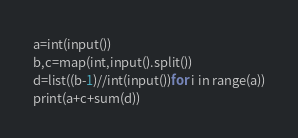<code> <loc_0><loc_0><loc_500><loc_500><_Python_>a=int(input())
b,c=map(int,input().split())
d=list((b-1)//int(input())for i in range(a))
print(a+c+sum(d))</code> 